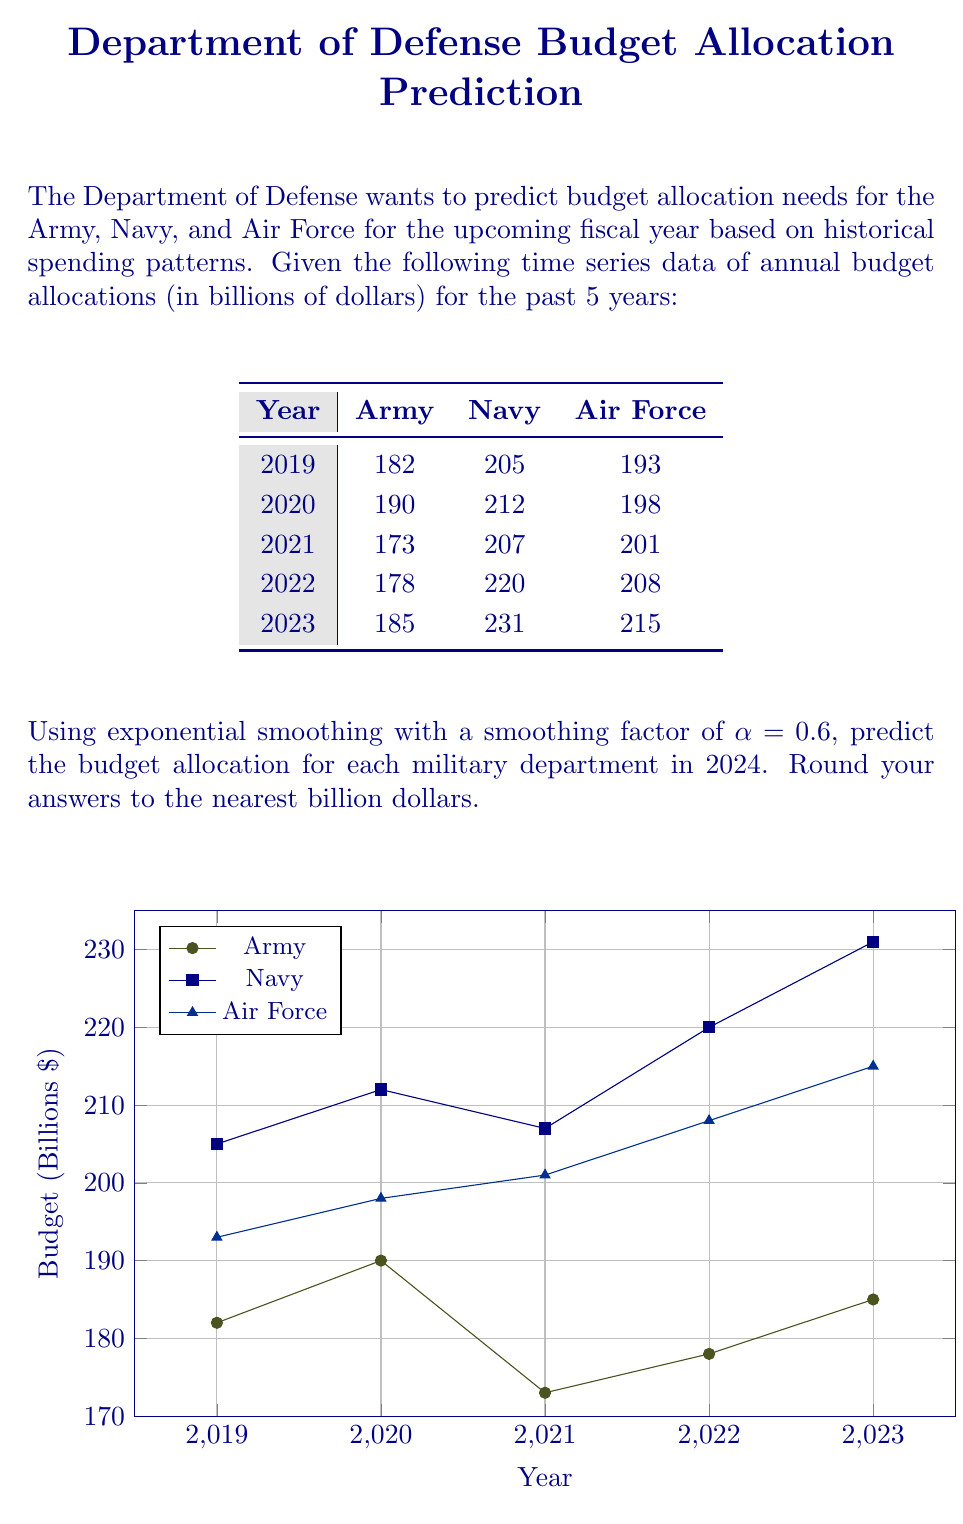Solve this math problem. To predict the budget allocation for 2024 using exponential smoothing, we'll use the formula:

$$F_{t+1} = \alpha Y_t + (1-\alpha)F_t$$

Where:
$F_{t+1}$ is the forecast for the next period
$\alpha$ is the smoothing factor (0.6 in this case)
$Y_t$ is the actual value for the current period
$F_t$ is the forecast for the current period

We'll start with the most recent forecast (2023) as our initial forecast and use the actual 2023 value to predict 2024.

For the Army:
$$F_{2024} = 0.6 * 185 + (1-0.6) * 185 = 111 + 74 = 185$$

For the Navy:
$$F_{2024} = 0.6 * 231 + (1-0.6) * 231 = 138.6 + 92.4 = 231$$

For the Air Force:
$$F_{2024} = 0.6 * 215 + (1-0.6) * 215 = 129 + 86 = 215$$

Rounding to the nearest billion:
Army: 185 billion
Navy: 231 billion
Air Force: 215 billion
Answer: Army: $185 billion, Navy: $231 billion, Air Force: $215 billion 